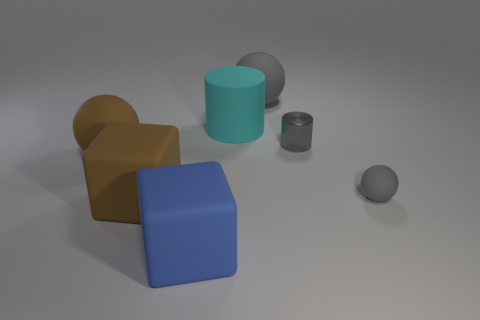Add 2 cyan matte cylinders. How many objects exist? 9 Subtract all cubes. How many objects are left? 5 Subtract all tiny balls. Subtract all brown objects. How many objects are left? 4 Add 2 cyan rubber cylinders. How many cyan rubber cylinders are left? 3 Add 5 tiny red matte things. How many tiny red matte things exist? 5 Subtract 1 gray spheres. How many objects are left? 6 